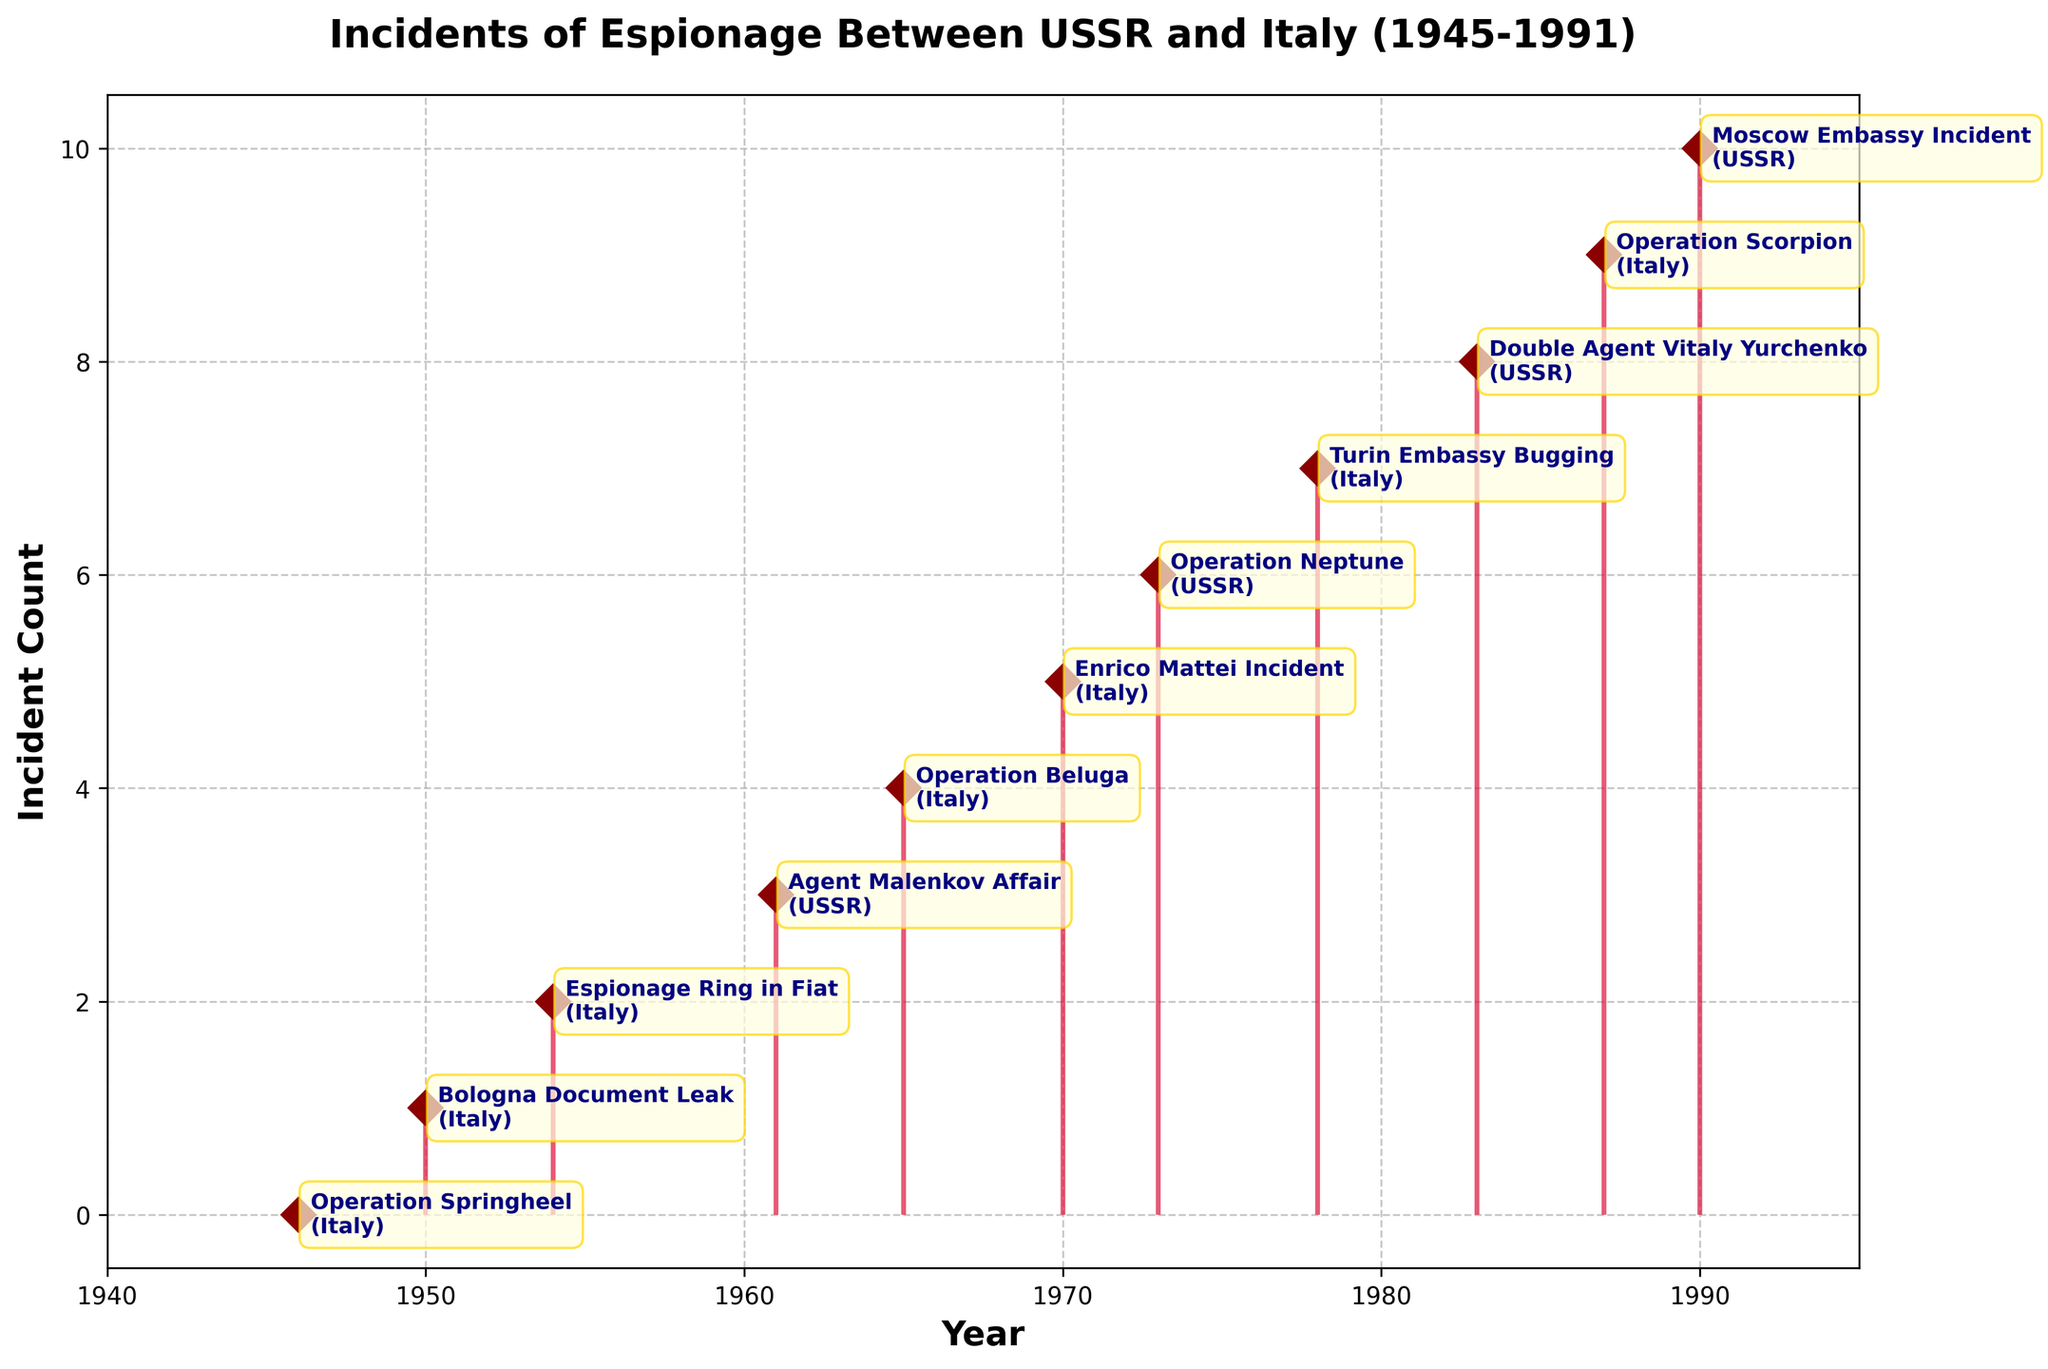In what year did the highest number of espionage incidents take place? The stem plot shows incidents over different years, with each incident having a specific position along the y-axis. By examining the plot year by year, we find that years with single counts of incidents are shown without any cumulative spikes in count. Thus, each year listed visually seems to have one incident.
Answer: Each year listed has one incident How many espionage incidents occurred in Italy? By examining the annotations beside each marker in the plot, we can count the number of incidents that list "Italy" as the country where the event took place.
Answer: Six Which incident associated with the USSR is plotted closest to the year 1985? From the stem plot, we locate the points where the USSR incidents appear; we see a 1983 incident called "Double Agent Vitaly Yurchenko" and a 1990 incident called "Moscow Embassy Incident." The 1983 incident is closer to 1985.
Answer: Double Agent Vitaly Yurchenko What is the overall trend in the number of incidents from 1945 to 1991? By observing the stem plot from left to right, we see the number of incidents displayed sporadically without an increasing or decreasing pattern across years. There’s no clear upward or downward trend.
Answer: No clear trend Calculate the gap in years between the “Agent Malenkov Affair” (USSR) and “Operation Beluga” (Italy). "Agent Malenkov Affair" occurred in 1961, and "Operation Beluga" in 1965. The gap between these two years is calculated as 1965 - 1961.
Answer: 4 years Which country had an espionage incident first and in what year? By examining the earliest point on the stem plot, we observe that "Operation Springheel" (Italy) happened in 1946. This is the first incident.
Answer: Italy, 1946 Are there any consecutive years with espionage incidents? A detailed look at the years of the incidents in the plot shows that no two incidents in consecutive years appear back to back.
Answer: No Which incident is closest in time to the "Turin Embassy Bugging" and in which country did it occur? The "Turin Embassy Bugging" occurred in 1978. By checking the neighboring incidents on the plot, we find the closest ones are "Operation Neptune" (1973) and "Double Agent Vitaly Yurchenko" (1983). "Double Agent Vitaly Yurchenko" is closer in 1983 and is listed as occurring in the USSR.
Answer: Double Agent Vitaly Yurchenko, USSR 